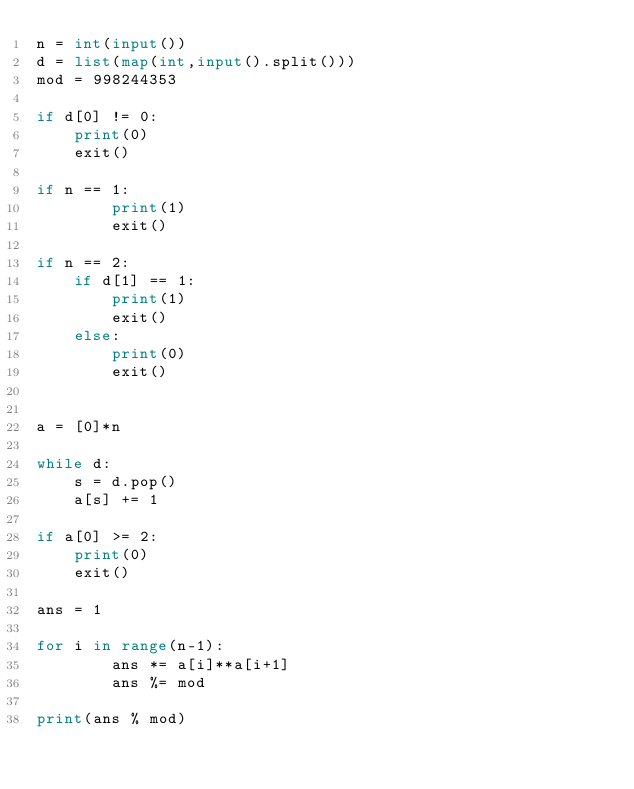Convert code to text. <code><loc_0><loc_0><loc_500><loc_500><_Python_>n = int(input())
d = list(map(int,input().split()))
mod = 998244353

if d[0] != 0:
    print(0)
    exit()

if n == 1:
        print(1)
        exit()

if n == 2:
    if d[1] == 1:
        print(1)
        exit()
    else:
        print(0)
        exit()


a = [0]*n

while d:
    s = d.pop()
    a[s] += 1

if a[0] >= 2:
    print(0)
    exit()

ans = 1

for i in range(n-1):
        ans *= a[i]**a[i+1]
        ans %= mod

print(ans % mod)</code> 